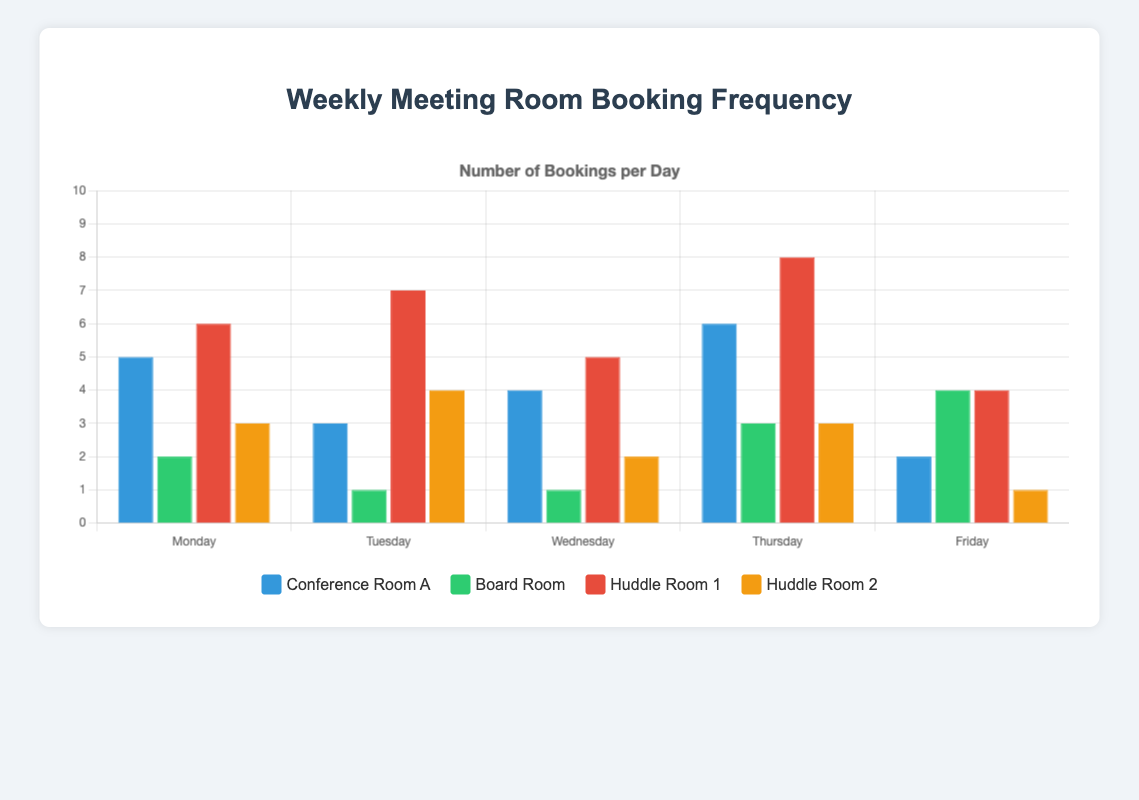What's the total number of bookings for Conference Room A throughout the week? To find the total number of bookings for Conference Room A, sum the values (5, 3, 4, 6, 2): 5 + 3 + 4 + 6 + 2 = 20
Answer: 20 Which meeting room has the highest number of bookings on Thursday? Look for the tallest bar on Thursday; Huddle Room 1 has 8 bookings on Thursday.
Answer: Huddle Room 1 How many more bookings did Huddle Room 1 have on Tuesday compared to the Board Room on Tuesday? Calculate the difference between bookings for Huddle Room 1 (7) and Board Room (1) on Tuesday: 7 - 1 = 6
Answer: 6 What is the average number of bookings for Huddle Room 2 across all days? Sum up the bookings (3, 4, 2, 3, 1) and divide by 5: (3 + 4 + 2 + 3 + 1) / 5 = 13 / 5 = 2.6
Answer: 2.6 On which day does Conference Room A have the fewest bookings? Look for the shortest bar for Conference Room A; it's the one on Friday with 2 bookings.
Answer: Friday Which meeting room shows more consistent booking behavior throughout the week? By comparing the differences between bars, Board Room has less variation (ranges from 1 to 4 bookings) compared to others.
Answer: Board Room How many total bookings were made on Monday across all rooms? Sum the bookings on Monday for each room (5 + 2 + 6 + 3): 5 + 2 + 6 + 3 = 16
Answer: 16 What is the color of the bars representing the bookings for Conference Room A? The legend shows Conference Room A is represented by blue bars.
Answer: Blue Which two meeting rooms have the same number of bookings on Friday? Check for matching bar heights on Friday; both Huddle Room 1 and Board Room have 4 bookings.
Answer: Huddle Room 1 and Board Room 